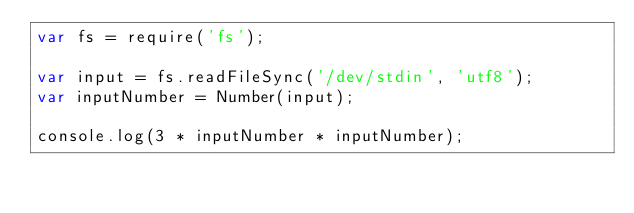Convert code to text. <code><loc_0><loc_0><loc_500><loc_500><_JavaScript_>var fs = require('fs');
     
var input = fs.readFileSync('/dev/stdin', 'utf8');
var inputNumber = Number(input);

console.log(3 * inputNumber * inputNumber);</code> 